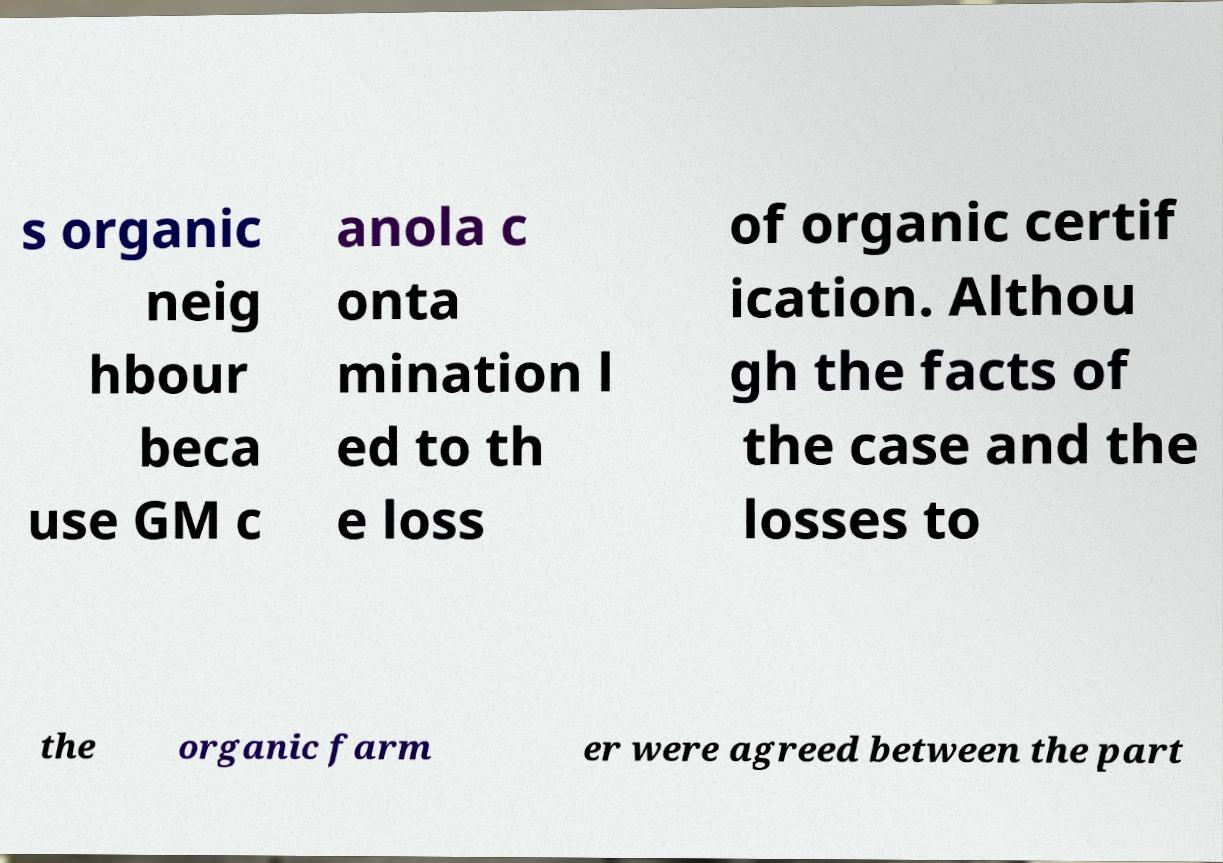I need the written content from this picture converted into text. Can you do that? s organic neig hbour beca use GM c anola c onta mination l ed to th e loss of organic certif ication. Althou gh the facts of the case and the losses to the organic farm er were agreed between the part 